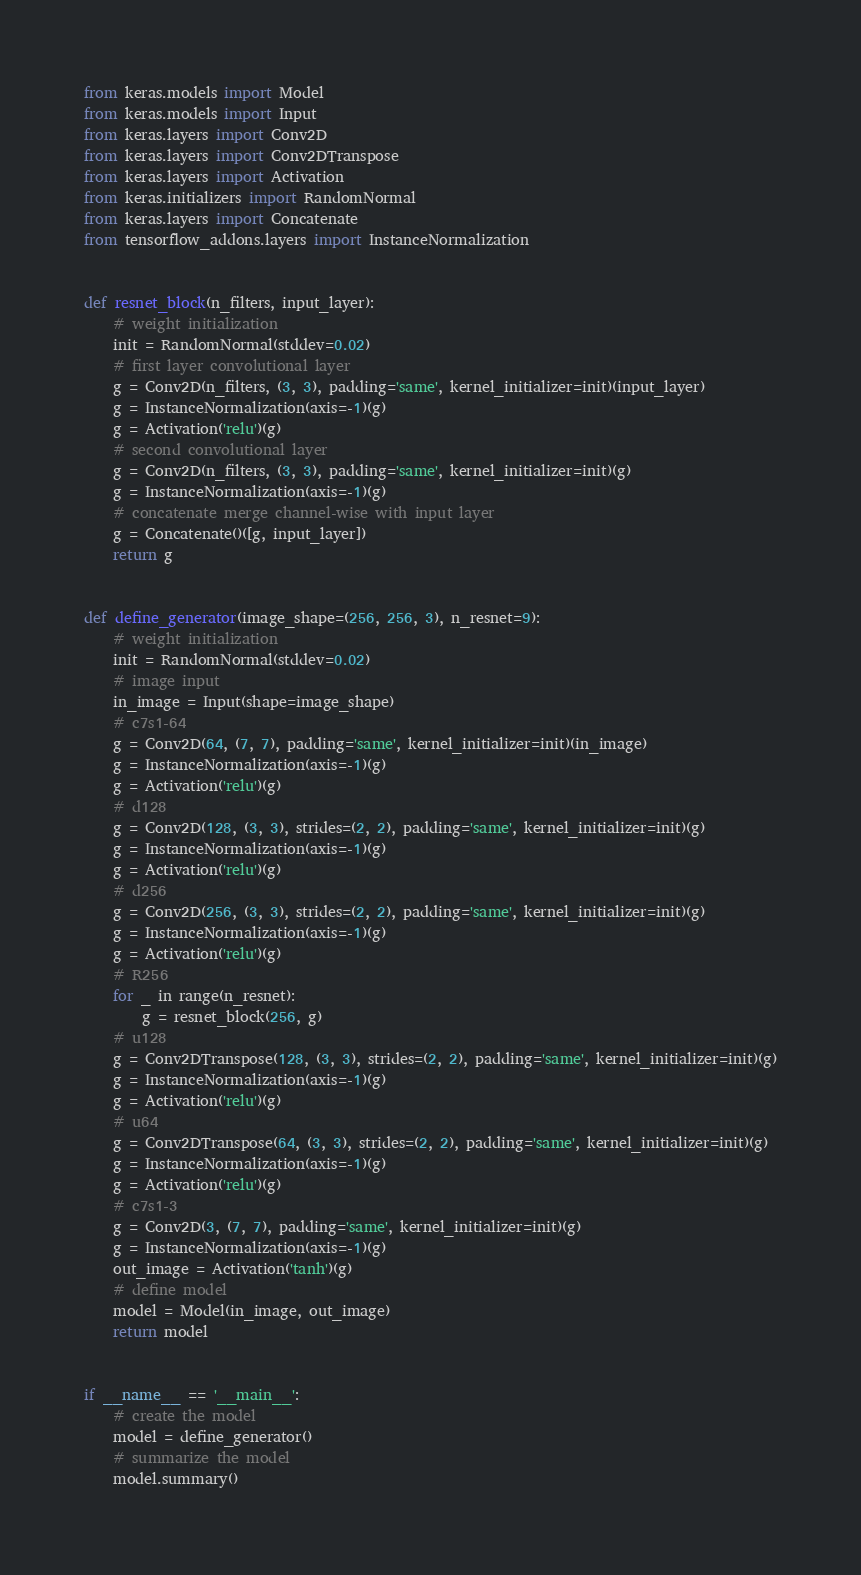Convert code to text. <code><loc_0><loc_0><loc_500><loc_500><_Python_>from keras.models import Model
from keras.models import Input
from keras.layers import Conv2D
from keras.layers import Conv2DTranspose
from keras.layers import Activation
from keras.initializers import RandomNormal
from keras.layers import Concatenate
from tensorflow_addons.layers import InstanceNormalization


def resnet_block(n_filters, input_layer):
    # weight initialization
    init = RandomNormal(stddev=0.02)
    # first layer convolutional layer
    g = Conv2D(n_filters, (3, 3), padding='same', kernel_initializer=init)(input_layer)
    g = InstanceNormalization(axis=-1)(g)
    g = Activation('relu')(g)
    # second convolutional layer
    g = Conv2D(n_filters, (3, 3), padding='same', kernel_initializer=init)(g)
    g = InstanceNormalization(axis=-1)(g)
    # concatenate merge channel-wise with input layer
    g = Concatenate()([g, input_layer])
    return g


def define_generator(image_shape=(256, 256, 3), n_resnet=9):
    # weight initialization
    init = RandomNormal(stddev=0.02)
    # image input
    in_image = Input(shape=image_shape)
    # c7s1-64
    g = Conv2D(64, (7, 7), padding='same', kernel_initializer=init)(in_image)
    g = InstanceNormalization(axis=-1)(g)
    g = Activation('relu')(g)
    # d128
    g = Conv2D(128, (3, 3), strides=(2, 2), padding='same', kernel_initializer=init)(g)
    g = InstanceNormalization(axis=-1)(g)
    g = Activation('relu')(g)
    # d256
    g = Conv2D(256, (3, 3), strides=(2, 2), padding='same', kernel_initializer=init)(g)
    g = InstanceNormalization(axis=-1)(g)
    g = Activation('relu')(g)
    # R256
    for _ in range(n_resnet):
        g = resnet_block(256, g)
    # u128
    g = Conv2DTranspose(128, (3, 3), strides=(2, 2), padding='same', kernel_initializer=init)(g)
    g = InstanceNormalization(axis=-1)(g)
    g = Activation('relu')(g)
    # u64
    g = Conv2DTranspose(64, (3, 3), strides=(2, 2), padding='same', kernel_initializer=init)(g)
    g = InstanceNormalization(axis=-1)(g)
    g = Activation('relu')(g)
    # c7s1-3
    g = Conv2D(3, (7, 7), padding='same', kernel_initializer=init)(g)
    g = InstanceNormalization(axis=-1)(g)
    out_image = Activation('tanh')(g)
    # define model
    model = Model(in_image, out_image)
    return model


if __name__ == '__main__':
    # create the model
    model = define_generator()
    # summarize the model
    model.summary()
</code> 